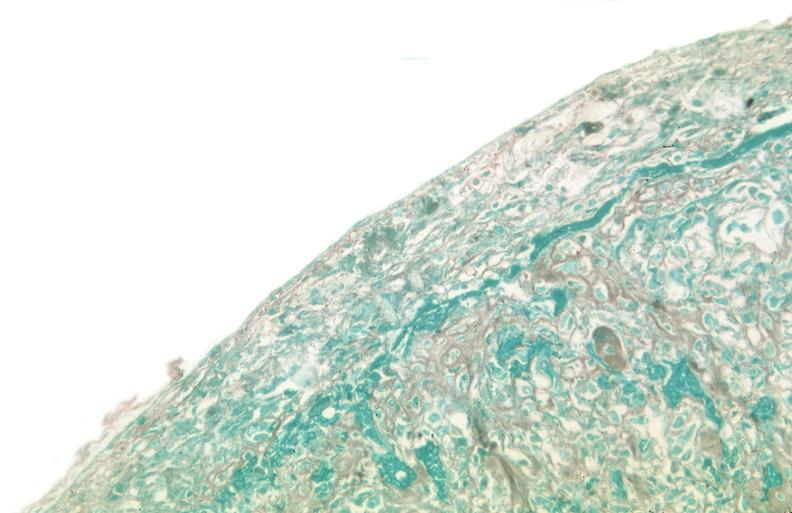what stain?
Answer the question using a single word or phrase. Trichrome 